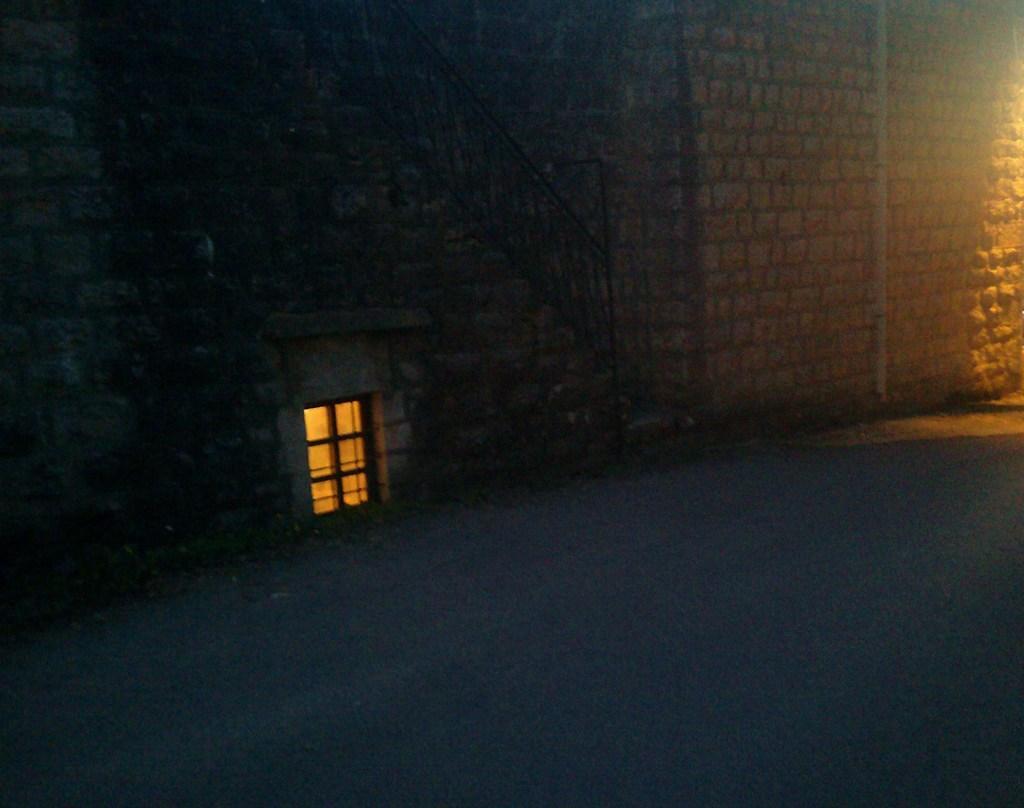Describe this image in one or two sentences. In this picture I can see a brick wall and a stairs and a glass window to the wall. 